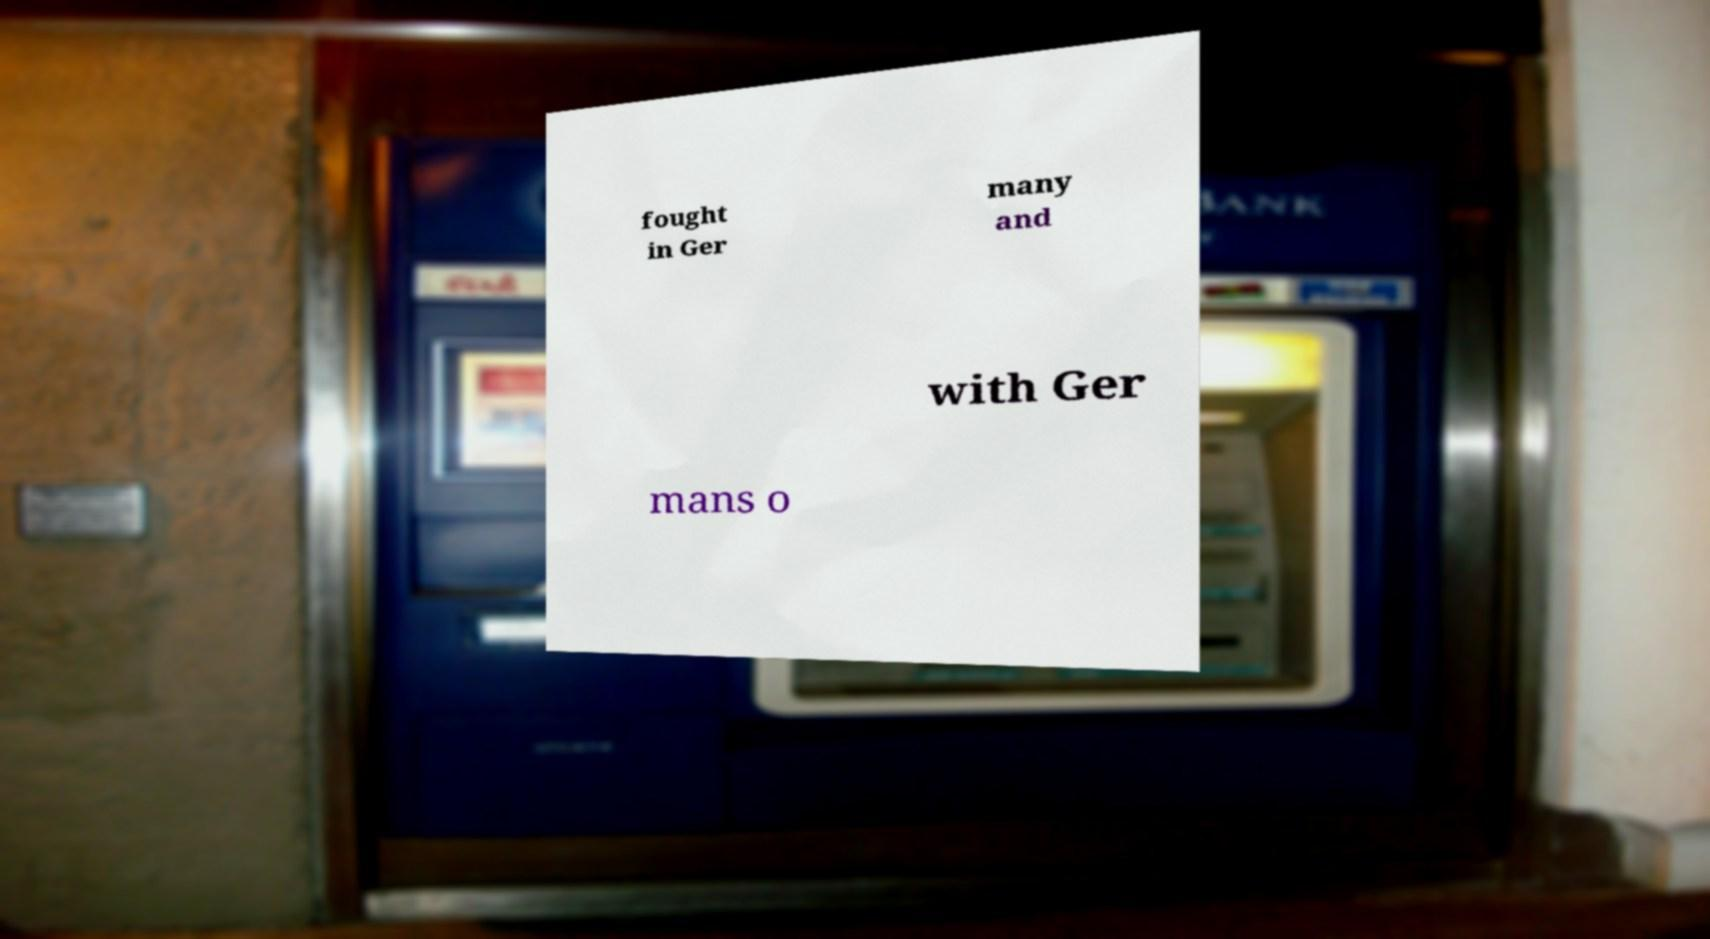What messages or text are displayed in this image? I need them in a readable, typed format. fought in Ger many and with Ger mans o 